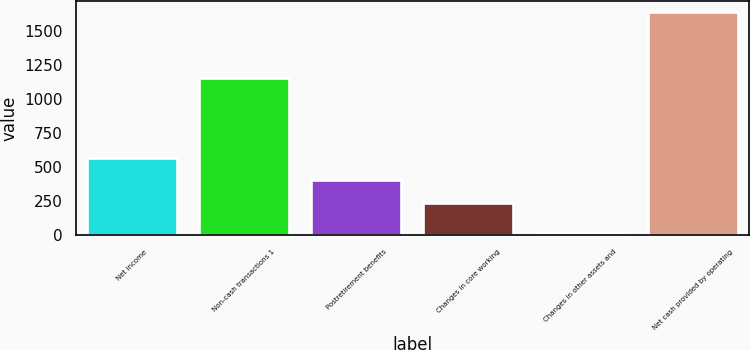<chart> <loc_0><loc_0><loc_500><loc_500><bar_chart><fcel>Net income<fcel>Non-cash transactions 1<fcel>Postretirement benefits<fcel>Changes in core working<fcel>Changes in other assets and<fcel>Net cash provided by operating<nl><fcel>565.2<fcel>1155<fcel>403.1<fcel>241<fcel>19<fcel>1640<nl></chart> 